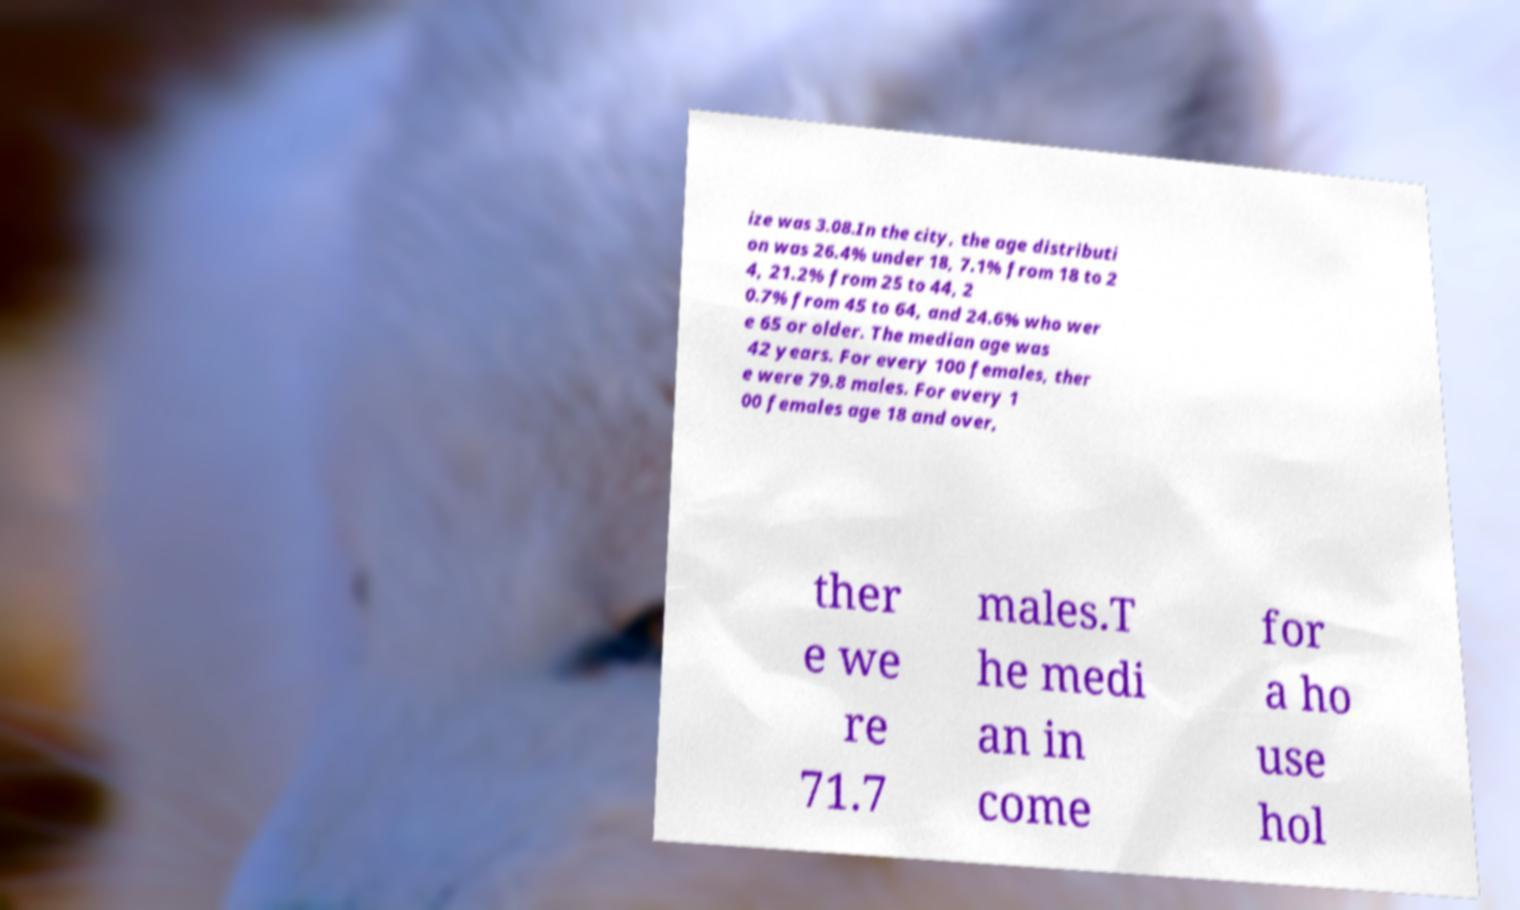I need the written content from this picture converted into text. Can you do that? ize was 3.08.In the city, the age distributi on was 26.4% under 18, 7.1% from 18 to 2 4, 21.2% from 25 to 44, 2 0.7% from 45 to 64, and 24.6% who wer e 65 or older. The median age was 42 years. For every 100 females, ther e were 79.8 males. For every 1 00 females age 18 and over, ther e we re 71.7 males.T he medi an in come for a ho use hol 